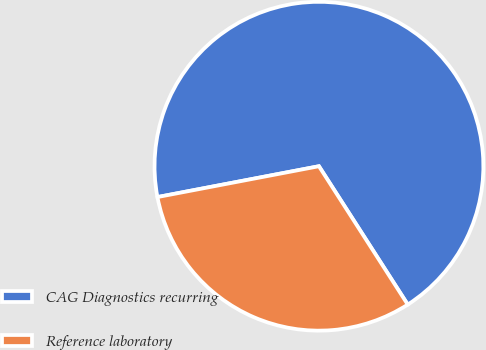Convert chart. <chart><loc_0><loc_0><loc_500><loc_500><pie_chart><fcel>CAG Diagnostics recurring<fcel>Reference laboratory<nl><fcel>68.92%<fcel>31.08%<nl></chart> 